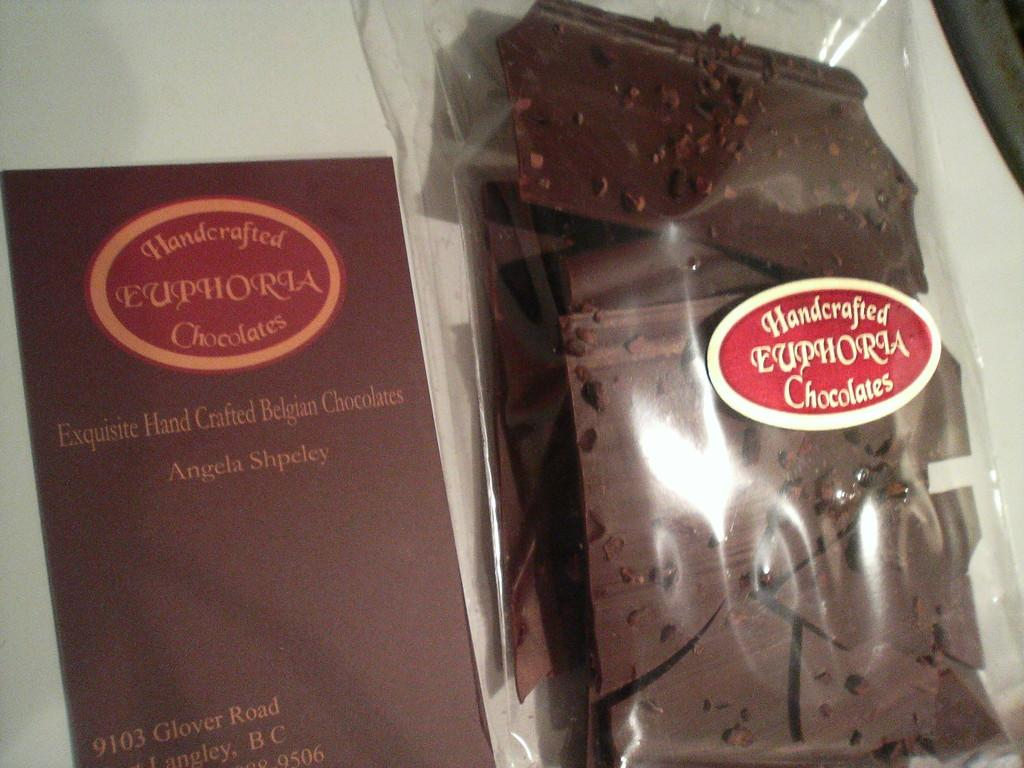<image>
Offer a succinct explanation of the picture presented. Exquisite Hand Crafted Belgian Chocolates look delicious and are attractively packaged. 